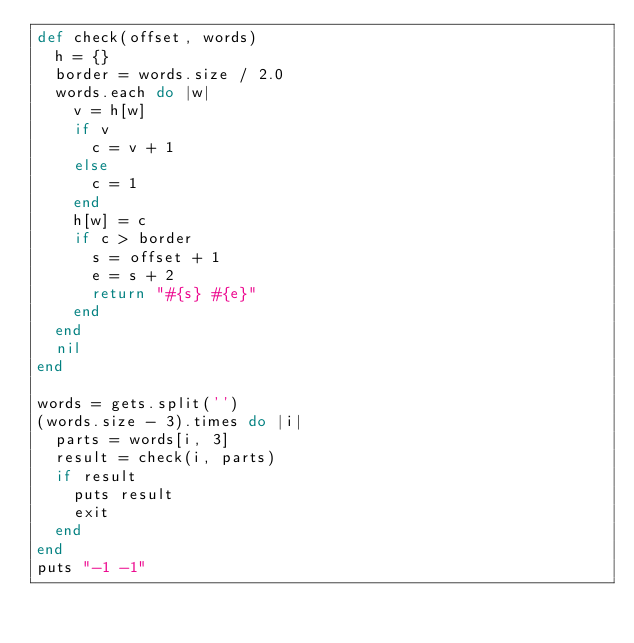<code> <loc_0><loc_0><loc_500><loc_500><_Ruby_>def check(offset, words)
  h = {}
  border = words.size / 2.0
  words.each do |w|
    v = h[w]
    if v
      c = v + 1
    else
      c = 1
    end
    h[w] = c
    if c > border
      s = offset + 1
      e = s + 2
      return "#{s} #{e}"
    end
  end
  nil
end

words = gets.split('')
(words.size - 3).times do |i|
  parts = words[i, 3]
  result = check(i, parts)
  if result
    puts result
    exit 
  end
end
puts "-1 -1"
                                         </code> 